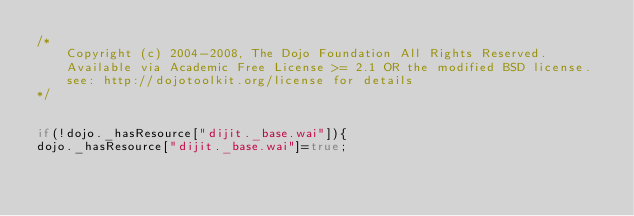<code> <loc_0><loc_0><loc_500><loc_500><_JavaScript_>/*
	Copyright (c) 2004-2008, The Dojo Foundation All Rights Reserved.
	Available via Academic Free License >= 2.1 OR the modified BSD license.
	see: http://dojotoolkit.org/license for details
*/


if(!dojo._hasResource["dijit._base.wai"]){
dojo._hasResource["dijit._base.wai"]=true;</code> 